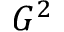<formula> <loc_0><loc_0><loc_500><loc_500>G ^ { 2 }</formula> 